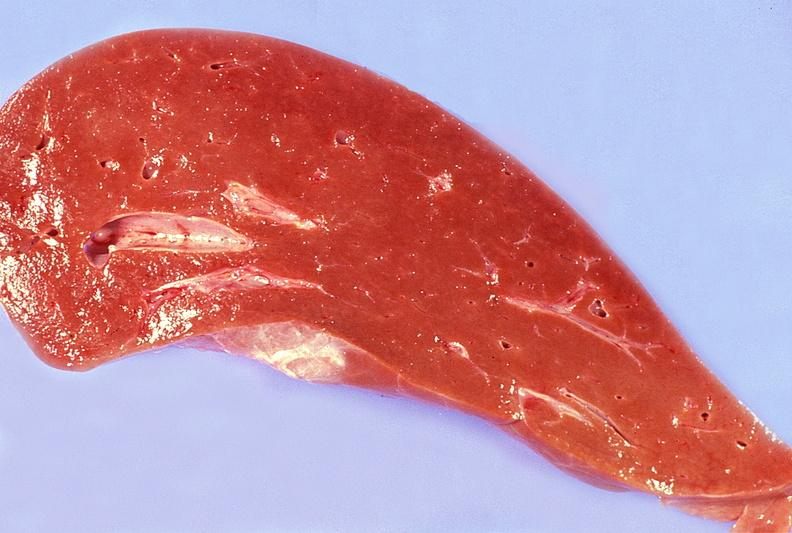does bone, calvarium show normal liver?
Answer the question using a single word or phrase. No 